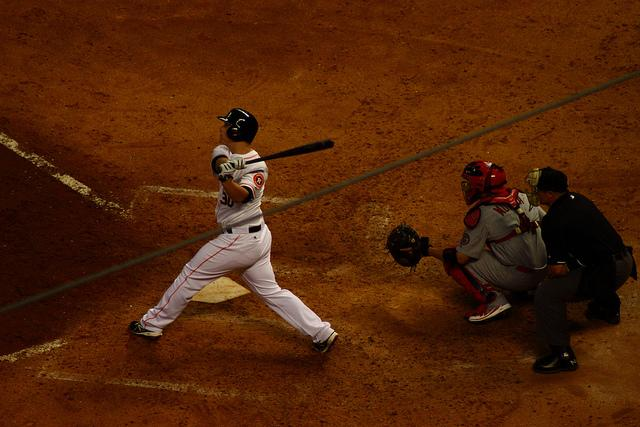What are the team colors for the team playing at pitch? white 